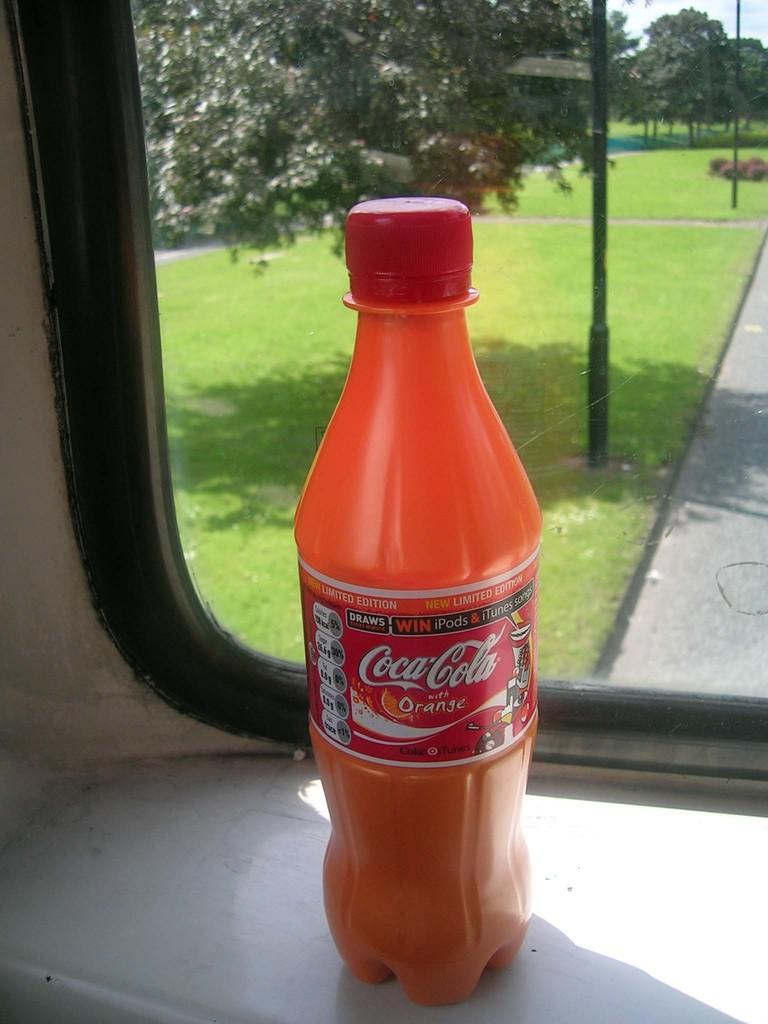<image>
Share a concise interpretation of the image provided. A bottle of Coca Cola in the flavor Orange is sitting in-front of a window. 